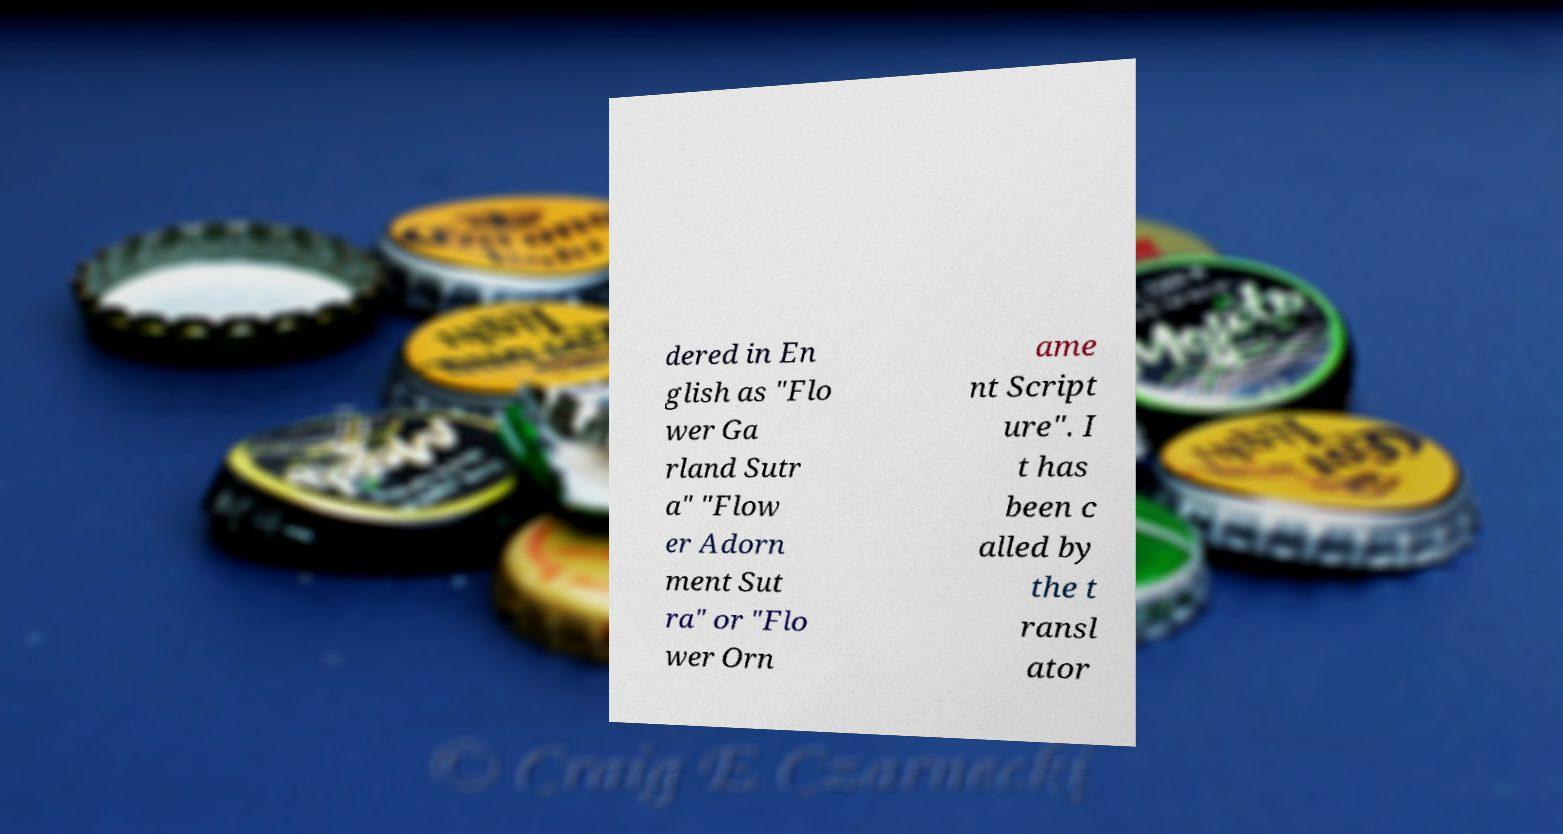Can you accurately transcribe the text from the provided image for me? dered in En glish as "Flo wer Ga rland Sutr a" "Flow er Adorn ment Sut ra" or "Flo wer Orn ame nt Script ure". I t has been c alled by the t ransl ator 